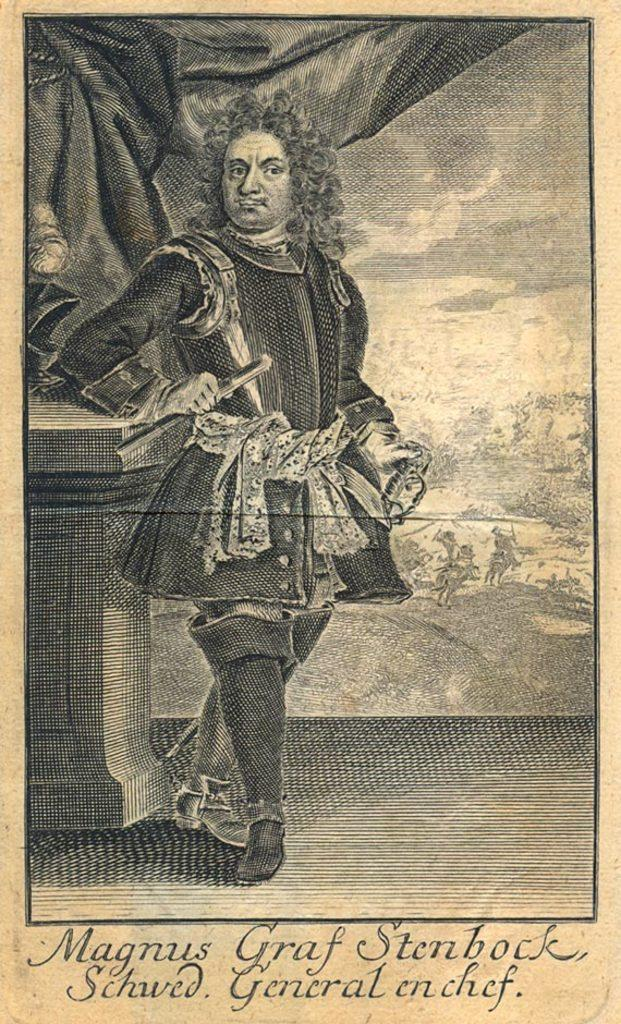What is present on the paper in the image? There is a black color dress depicted on the paper. Can you describe the dress shown on the paper? The dress is depicted in black color on the paper. What type of digestion process is happening to the dress in the image? There is no digestion process happening to the dress in the image; it is a depiction on a paper. What type of game is being played with the dress in the image? There is no game being played with the dress in the image; it is a depiction on a paper. 